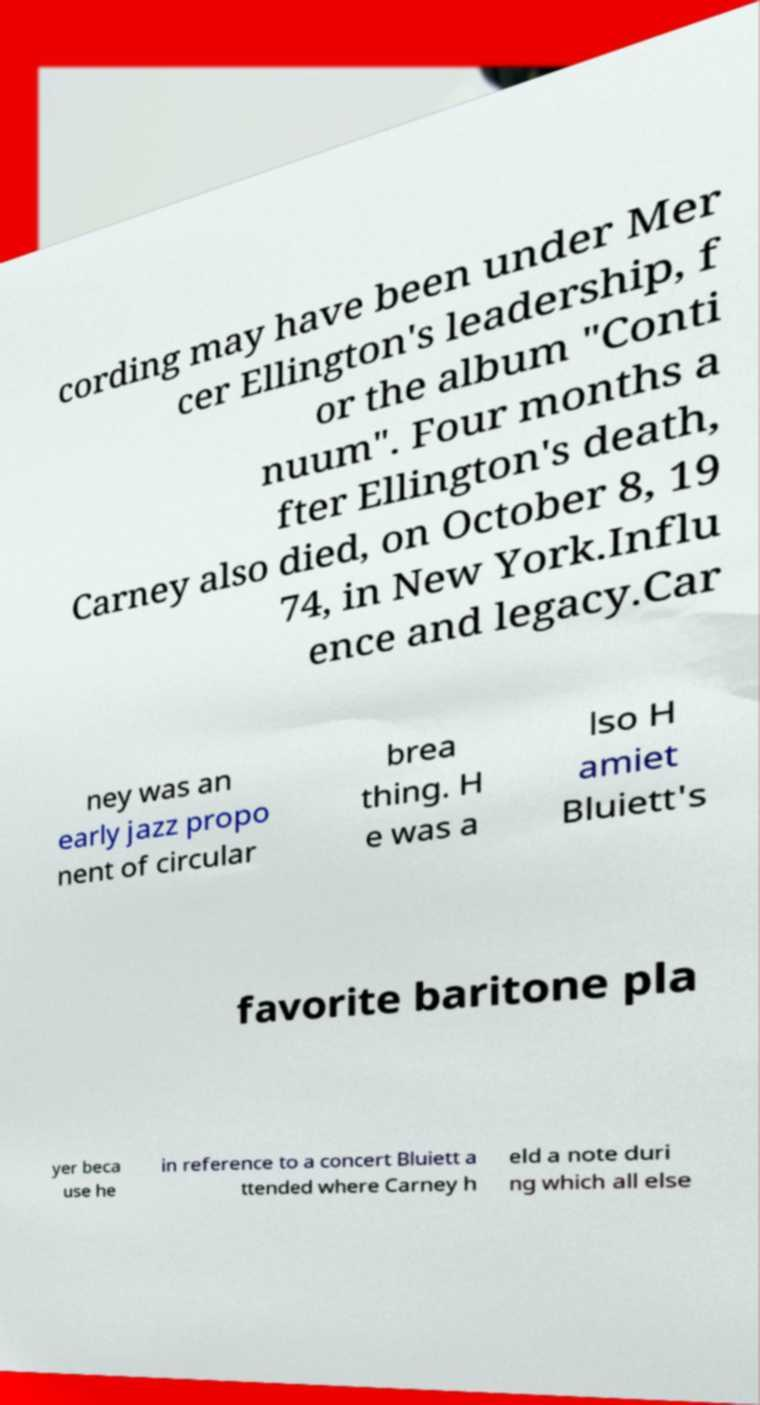I need the written content from this picture converted into text. Can you do that? cording may have been under Mer cer Ellington's leadership, f or the album "Conti nuum". Four months a fter Ellington's death, Carney also died, on October 8, 19 74, in New York.Influ ence and legacy.Car ney was an early jazz propo nent of circular brea thing. H e was a lso H amiet Bluiett's favorite baritone pla yer beca use he in reference to a concert Bluiett a ttended where Carney h eld a note duri ng which all else 